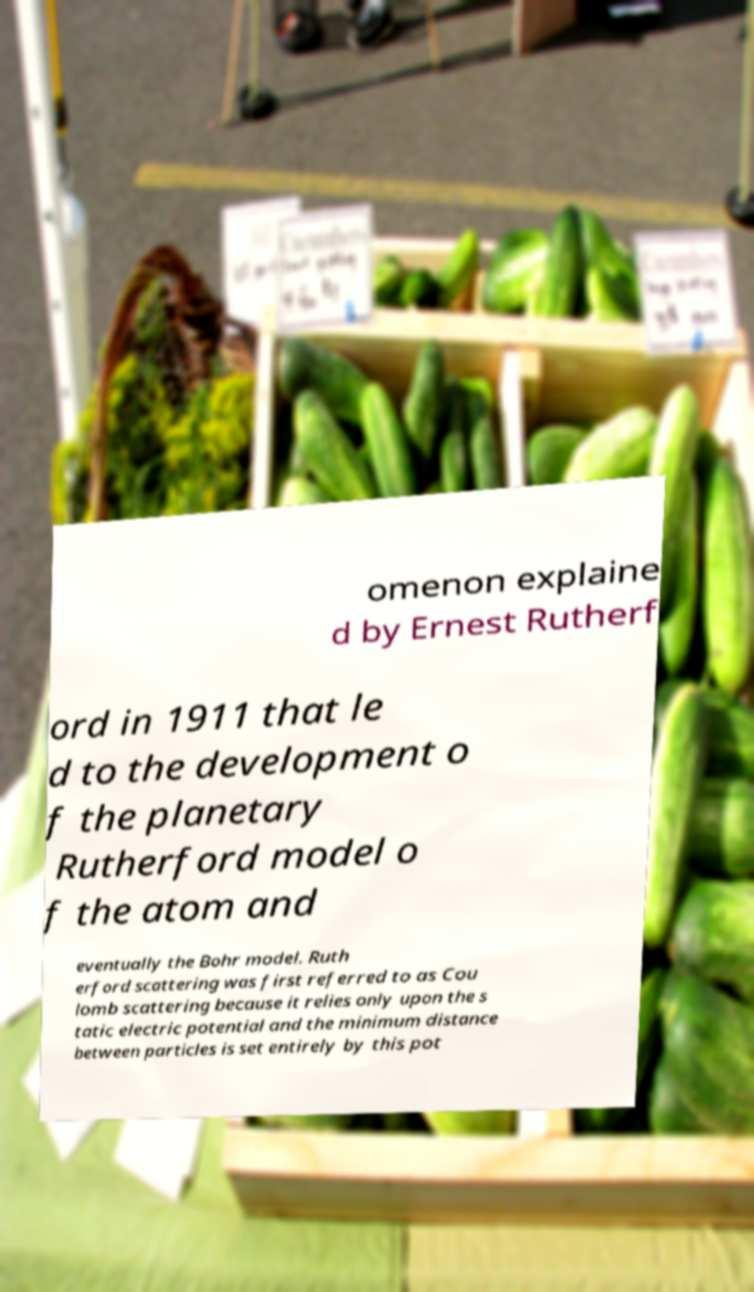Please identify and transcribe the text found in this image. omenon explaine d by Ernest Rutherf ord in 1911 that le d to the development o f the planetary Rutherford model o f the atom and eventually the Bohr model. Ruth erford scattering was first referred to as Cou lomb scattering because it relies only upon the s tatic electric potential and the minimum distance between particles is set entirely by this pot 